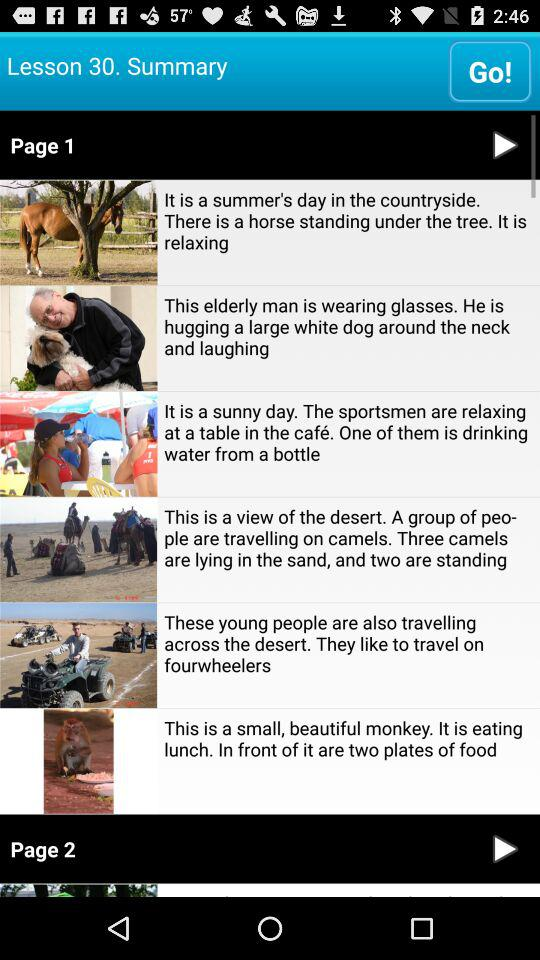What is the first story on page 2?
When the provided information is insufficient, respond with <no answer>. <no answer> 